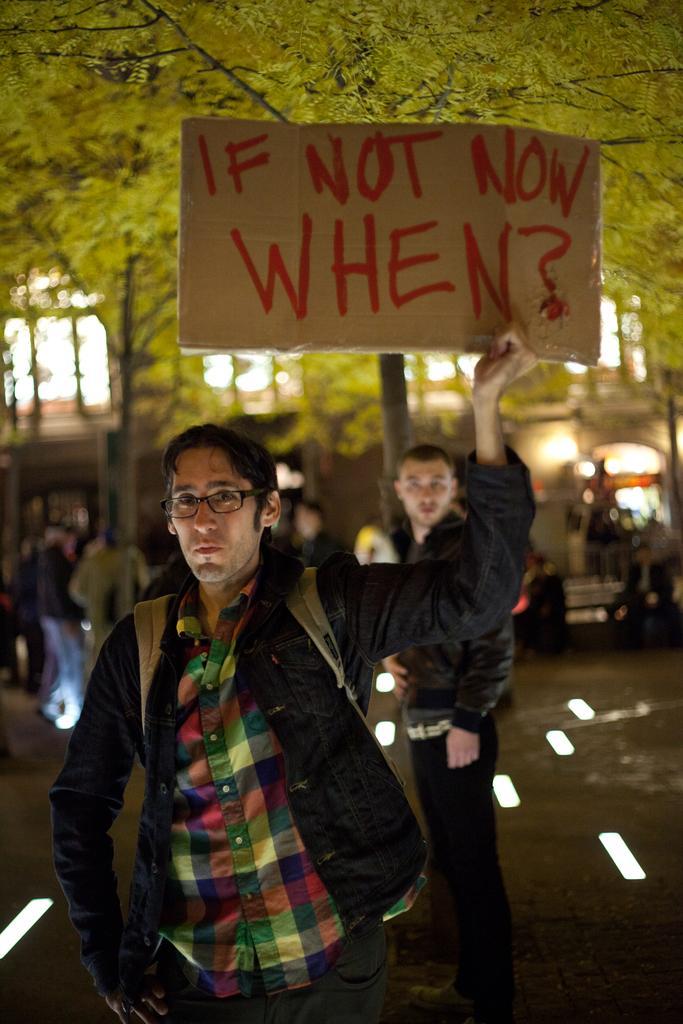Can you describe this image briefly? Front this person is holding a poster. Background we can see people, windows and vehicle. 